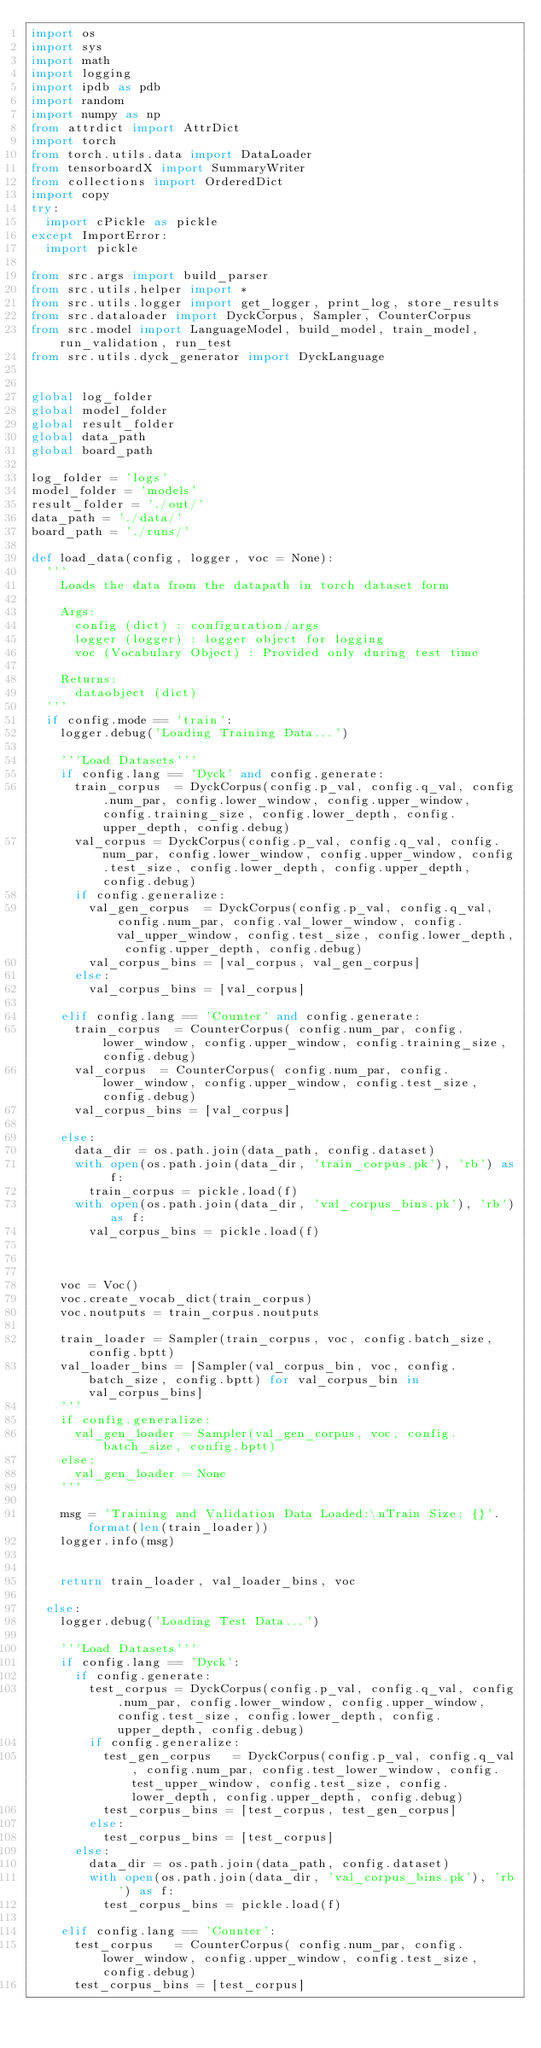Convert code to text. <code><loc_0><loc_0><loc_500><loc_500><_Python_>import os
import sys
import math
import logging
import ipdb as pdb
import random
import numpy as np
from attrdict import AttrDict
import torch
from torch.utils.data import DataLoader
from tensorboardX import SummaryWriter
from collections import OrderedDict
import copy
try:
	import cPickle as pickle
except ImportError:
	import pickle

from src.args import build_parser
from src.utils.helper import *
from src.utils.logger import get_logger, print_log, store_results
from src.dataloader import DyckCorpus, Sampler, CounterCorpus
from src.model import LanguageModel, build_model, train_model, run_validation, run_test
from src.utils.dyck_generator import DyckLanguage


global log_folder
global model_folder
global result_folder
global data_path
global board_path

log_folder = 'logs'
model_folder = 'models'
result_folder = './out/'
data_path = './data/'
board_path = './runs/'

def load_data(config, logger, voc = None):
	'''
		Loads the data from the datapath in torch dataset form

		Args:
			config (dict) : configuration/args
			logger (logger) : logger object for logging
			voc (Vocabulary Object) : Provided only during test time

		Returns:
			dataobject (dict) 
	'''
	if config.mode == 'train':
		logger.debug('Loading Training Data...')

		'''Load Datasets'''
		if config.lang == 'Dyck' and config.generate:
			train_corpus 	= DyckCorpus(config.p_val, config.q_val, config.num_par, config.lower_window, config.upper_window, config.training_size, config.lower_depth, config.upper_depth, config.debug)
			val_corpus = DyckCorpus(config.p_val, config.q_val, config.num_par, config.lower_window, config.upper_window, config.test_size, config.lower_depth, config.upper_depth, config.debug)
			if config.generalize:
				val_gen_corpus 	= DyckCorpus(config.p_val, config.q_val, config.num_par, config.val_lower_window, config.val_upper_window, config.test_size, config.lower_depth, config.upper_depth, config.debug)
				val_corpus_bins = [val_corpus, val_gen_corpus]
			else:
				val_corpus_bins = [val_corpus]

		elif config.lang == 'Counter' and config.generate:
			train_corpus 	= CounterCorpus( config.num_par, config.lower_window, config.upper_window, config.training_size, config.debug)
			val_corpus 	= CounterCorpus( config.num_par, config.lower_window, config.upper_window, config.test_size, config.debug)
			val_corpus_bins = [val_corpus]

		else:
			data_dir = os.path.join(data_path, config.dataset)
			with open(os.path.join(data_dir, 'train_corpus.pk'), 'rb') as f:
				train_corpus = pickle.load(f)
			with open(os.path.join(data_dir, 'val_corpus_bins.pk'), 'rb') as f:
				val_corpus_bins = pickle.load(f)



		voc = Voc()
		voc.create_vocab_dict(train_corpus)
		voc.noutputs = train_corpus.noutputs

		train_loader = Sampler(train_corpus, voc, config.batch_size, config.bptt)
		val_loader_bins = [Sampler(val_corpus_bin, voc, config.batch_size, config.bptt) for val_corpus_bin in val_corpus_bins]
		'''
		if config.generalize:
			val_gen_loader = Sampler(val_gen_corpus, voc, config.batch_size, config.bptt)
		else:
			val_gen_loader = None
		'''

		msg = 'Training and Validation Data Loaded:\nTrain Size: {}'.format(len(train_loader))
		logger.info(msg)


		return train_loader, val_loader_bins, voc

	else:
		logger.debug('Loading Test Data...')

		'''Load Datasets'''
		if config.lang == 'Dyck':
			if config.generate:
				test_corpus = DyckCorpus(config.p_val, config.q_val, config.num_par, config.lower_window, config.upper_window, config.test_size, config.lower_depth, config.upper_depth, config.debug)
				if config.generalize:
					test_gen_corpus 	= DyckCorpus(config.p_val, config.q_val, config.num_par, config.test_lower_window, config.test_upper_window, config.test_size, config.lower_depth, config.upper_depth, config.debug)
					test_corpus_bins = [test_corpus, test_gen_corpus]
				else:
					test_corpus_bins = [test_corpus]
			else:
				data_dir = os.path.join(data_path, config.dataset)
				with open(os.path.join(data_dir, 'val_corpus_bins.pk'), 'rb') as f:
					test_corpus_bins = pickle.load(f)

		elif config.lang == 'Counter':
			test_corpus 	= CounterCorpus( config.num_par, config.lower_window, config.upper_window, config.test_size, config.debug)
			test_corpus_bins = [test_corpus]
</code> 